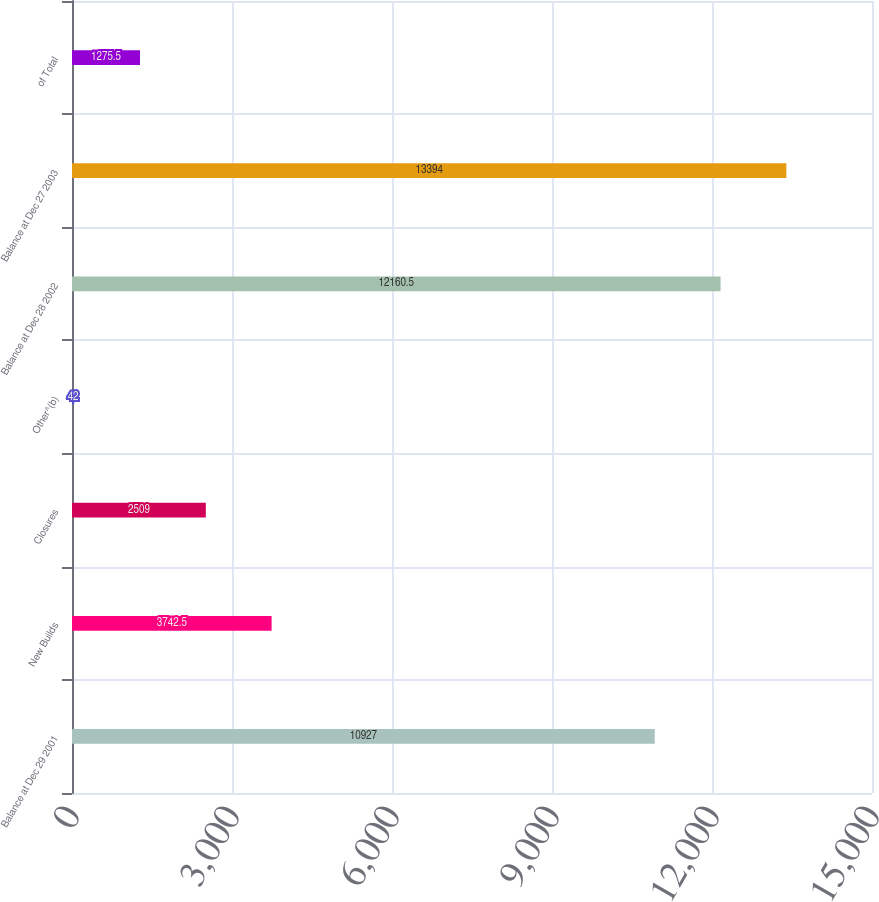<chart> <loc_0><loc_0><loc_500><loc_500><bar_chart><fcel>Balance at Dec 29 2001<fcel>New Builds<fcel>Closures<fcel>Other^(b)<fcel>Balance at Dec 28 2002<fcel>Balance at Dec 27 2003<fcel>of Total<nl><fcel>10927<fcel>3742.5<fcel>2509<fcel>42<fcel>12160.5<fcel>13394<fcel>1275.5<nl></chart> 